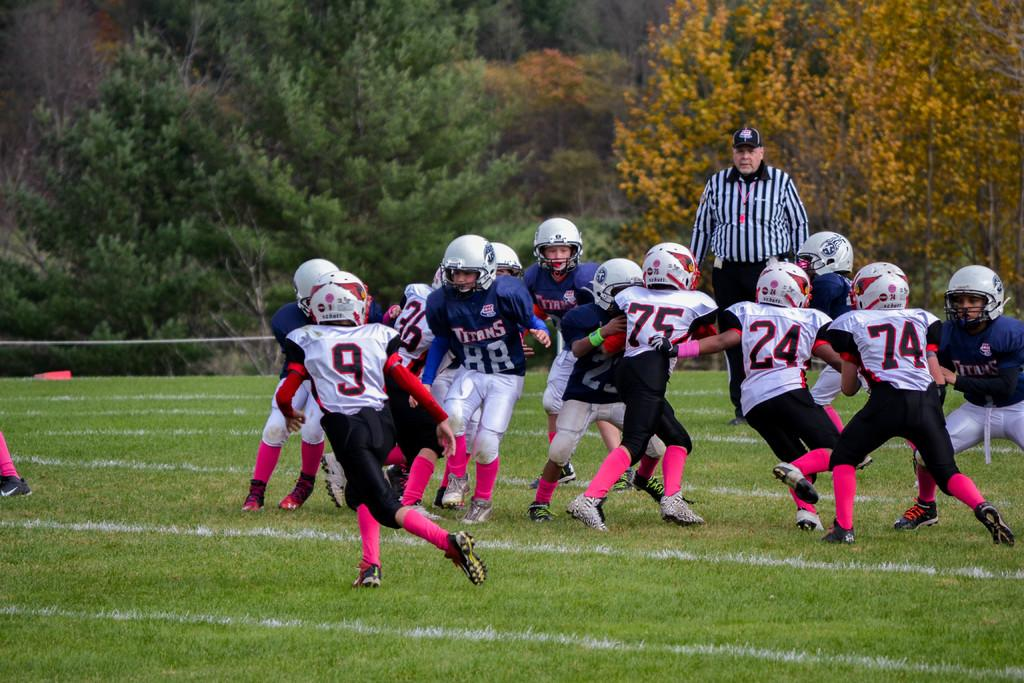What are the players doing in the image? The players are playing on the grass in the image. What is the position of the players in relation to the ground? The players are on the ground. Can you describe the background of the image? There is a person watching them and trees in the background of the image. What is the name of the person causing trouble on the roof in the image? There is no person causing trouble on the roof in the image. 